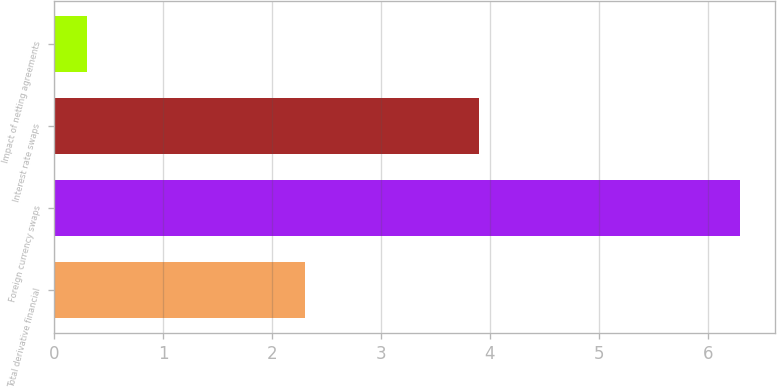Convert chart to OTSL. <chart><loc_0><loc_0><loc_500><loc_500><bar_chart><fcel>Total derivative financial<fcel>Foreign currency swaps<fcel>Interest rate swaps<fcel>Impact of netting agreements<nl><fcel>2.3<fcel>6.3<fcel>3.9<fcel>0.3<nl></chart> 